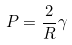Convert formula to latex. <formula><loc_0><loc_0><loc_500><loc_500>P = \frac { 2 } { R } \gamma</formula> 